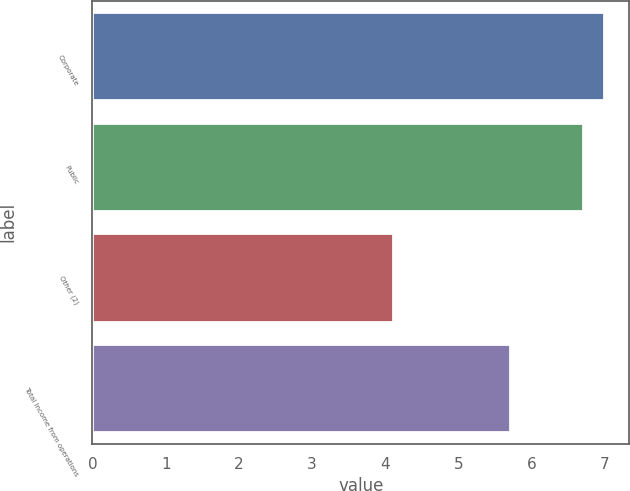Convert chart. <chart><loc_0><loc_0><loc_500><loc_500><bar_chart><fcel>Corporate<fcel>Public<fcel>Other (2)<fcel>Total Income from operations<nl><fcel>6.98<fcel>6.7<fcel>4.1<fcel>5.7<nl></chart> 